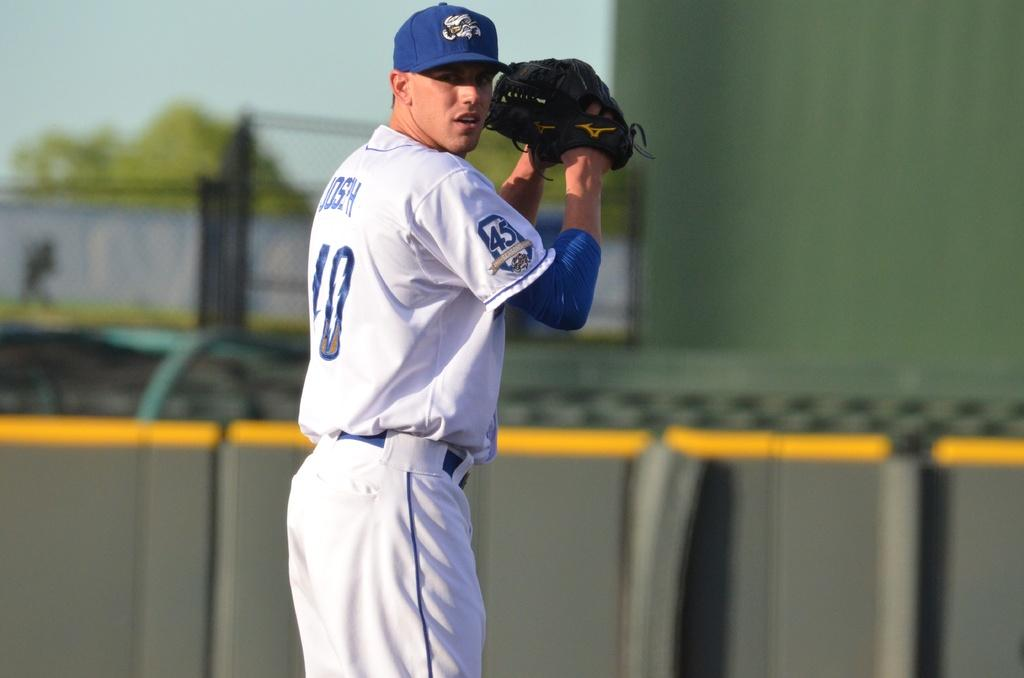Provide a one-sentence caption for the provided image. The players name is Joseph and he is wearing number 10. 